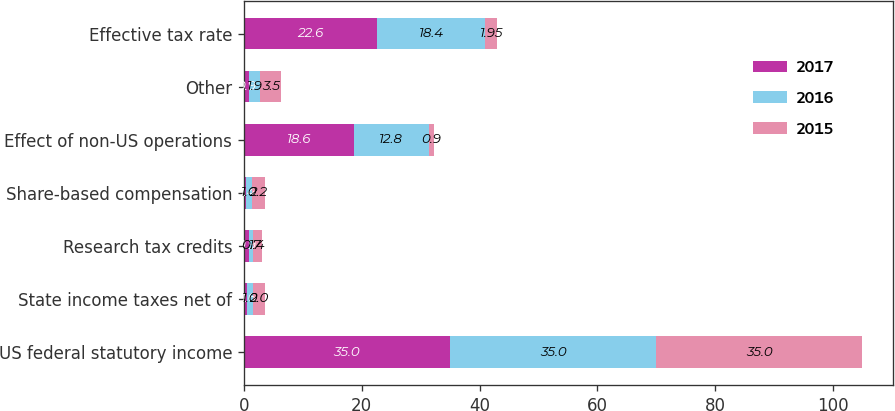<chart> <loc_0><loc_0><loc_500><loc_500><stacked_bar_chart><ecel><fcel>US federal statutory income<fcel>State income taxes net of<fcel>Research tax credits<fcel>Share-based compensation<fcel>Effect of non-US operations<fcel>Other<fcel>Effective tax rate<nl><fcel>2017<fcel>35<fcel>0.6<fcel>0.9<fcel>0.4<fcel>18.6<fcel>0.9<fcel>22.6<nl><fcel>2016<fcel>35<fcel>1<fcel>0.7<fcel>1<fcel>12.8<fcel>1.9<fcel>18.4<nl><fcel>2015<fcel>35<fcel>2<fcel>1.4<fcel>2.2<fcel>0.9<fcel>3.5<fcel>1.95<nl></chart> 